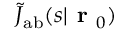<formula> <loc_0><loc_0><loc_500><loc_500>\tilde { J } _ { a b } ( s | r _ { 0 } )</formula> 